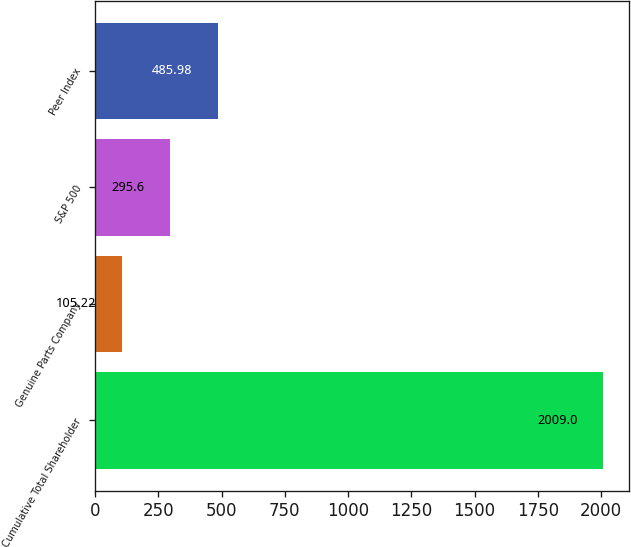<chart> <loc_0><loc_0><loc_500><loc_500><bar_chart><fcel>Cumulative Total Shareholder<fcel>Genuine Parts Company<fcel>S&P 500<fcel>Peer Index<nl><fcel>2009<fcel>105.22<fcel>295.6<fcel>485.98<nl></chart> 